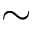Convert formula to latex. <formula><loc_0><loc_0><loc_500><loc_500>\sim</formula> 